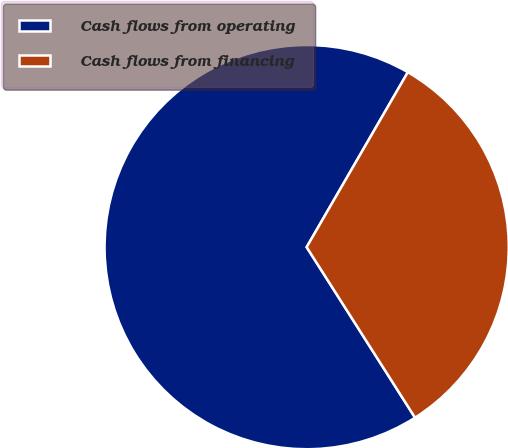Convert chart to OTSL. <chart><loc_0><loc_0><loc_500><loc_500><pie_chart><fcel>Cash flows from operating<fcel>Cash flows from financing<nl><fcel>67.36%<fcel>32.64%<nl></chart> 